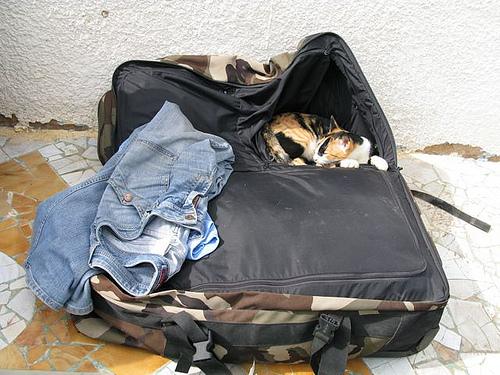What color is the bag?
Answer briefly. Black. Is the bag on the ground?
Short answer required. Yes. What is sleeping in the bag?
Concise answer only. Cat. Is the cat alert?
Short answer required. No. 